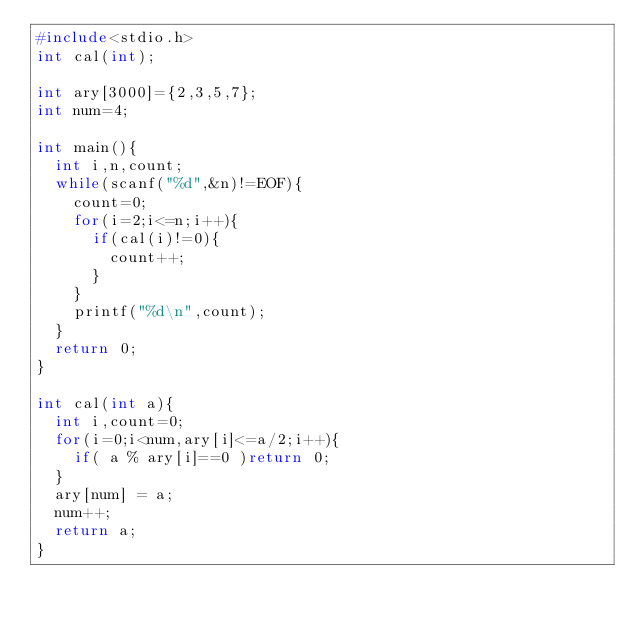Convert code to text. <code><loc_0><loc_0><loc_500><loc_500><_C_>#include<stdio.h>
int cal(int);

int ary[3000]={2,3,5,7};
int num=4;

int main(){
	int i,n,count;
	while(scanf("%d",&n)!=EOF){
		count=0;
		for(i=2;i<=n;i++){
			if(cal(i)!=0){
				count++;
			}
		}
		printf("%d\n",count);
	}
	return 0;
}

int cal(int a){
	int i,count=0;
	for(i=0;i<num,ary[i]<=a/2;i++){
		if( a % ary[i]==0 )return 0;
	}
	ary[num] = a;
	num++;
	return a;
}</code> 